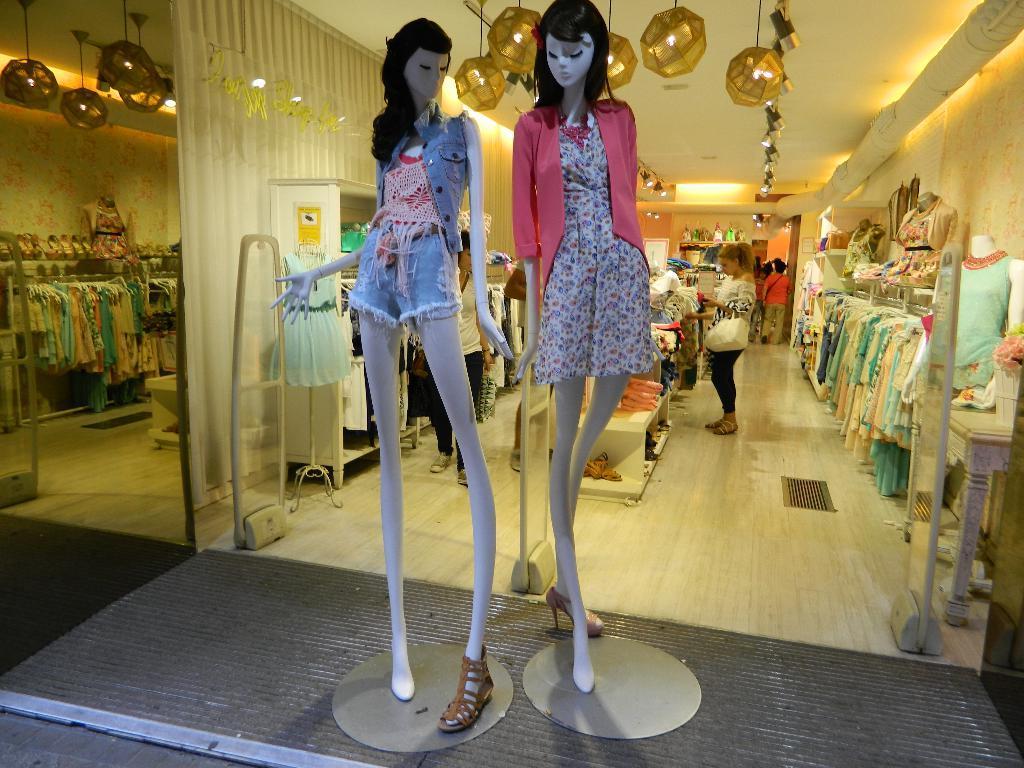In one or two sentences, can you explain what this image depicts? In the picture I can see mannequins which has clothes on them. In the background I can see people, clothes, lights on the ceiling, walls and some other objects. 